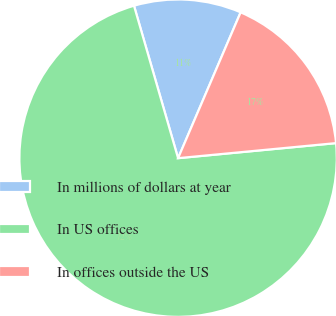Convert chart to OTSL. <chart><loc_0><loc_0><loc_500><loc_500><pie_chart><fcel>In millions of dollars at year<fcel>In US offices<fcel>In offices outside the US<nl><fcel>10.93%<fcel>72.04%<fcel>17.04%<nl></chart> 